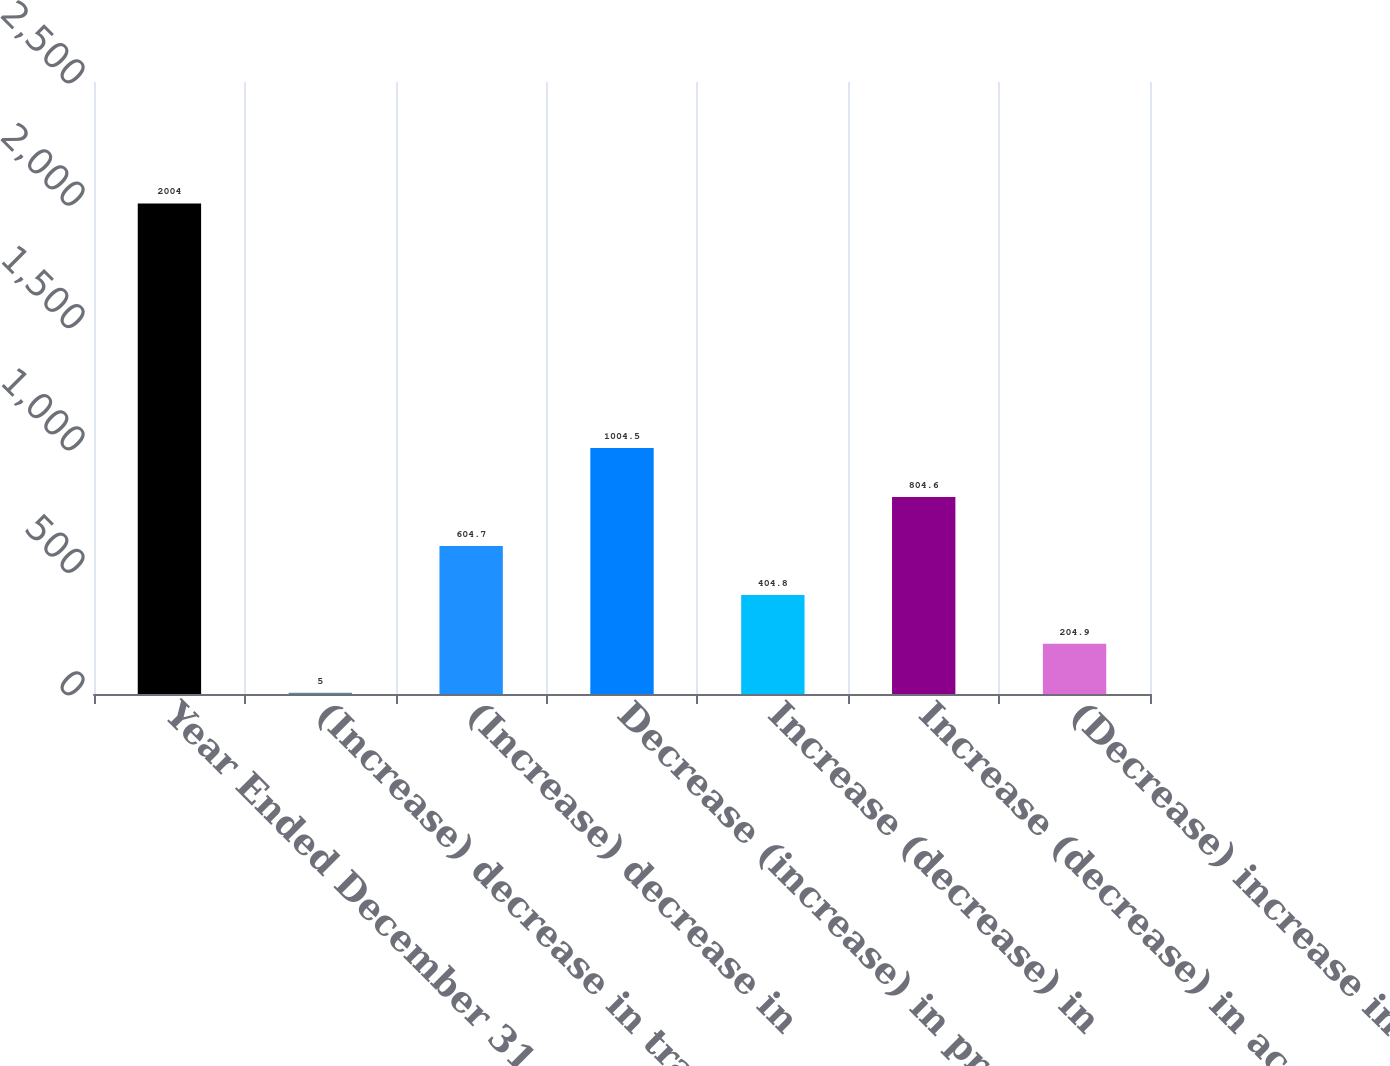Convert chart. <chart><loc_0><loc_0><loc_500><loc_500><bar_chart><fcel>Year Ended December 31<fcel>(Increase) decrease in trade<fcel>(Increase) decrease in<fcel>Decrease (increase) in prepaid<fcel>Increase (decrease) in<fcel>Increase (decrease) in accrued<fcel>(Decrease) increase in other<nl><fcel>2004<fcel>5<fcel>604.7<fcel>1004.5<fcel>404.8<fcel>804.6<fcel>204.9<nl></chart> 